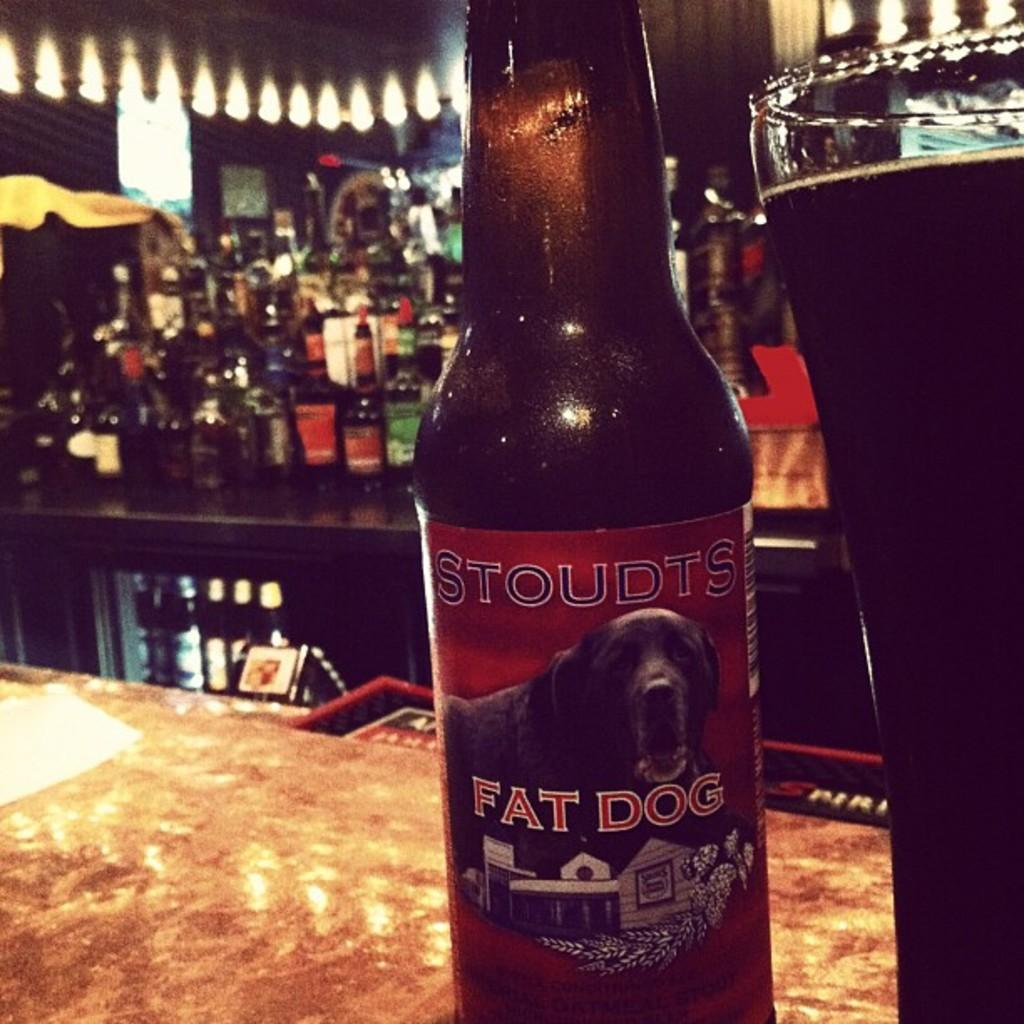<image>
Present a compact description of the photo's key features. A bottle of Fat Dog sits on a bar. 